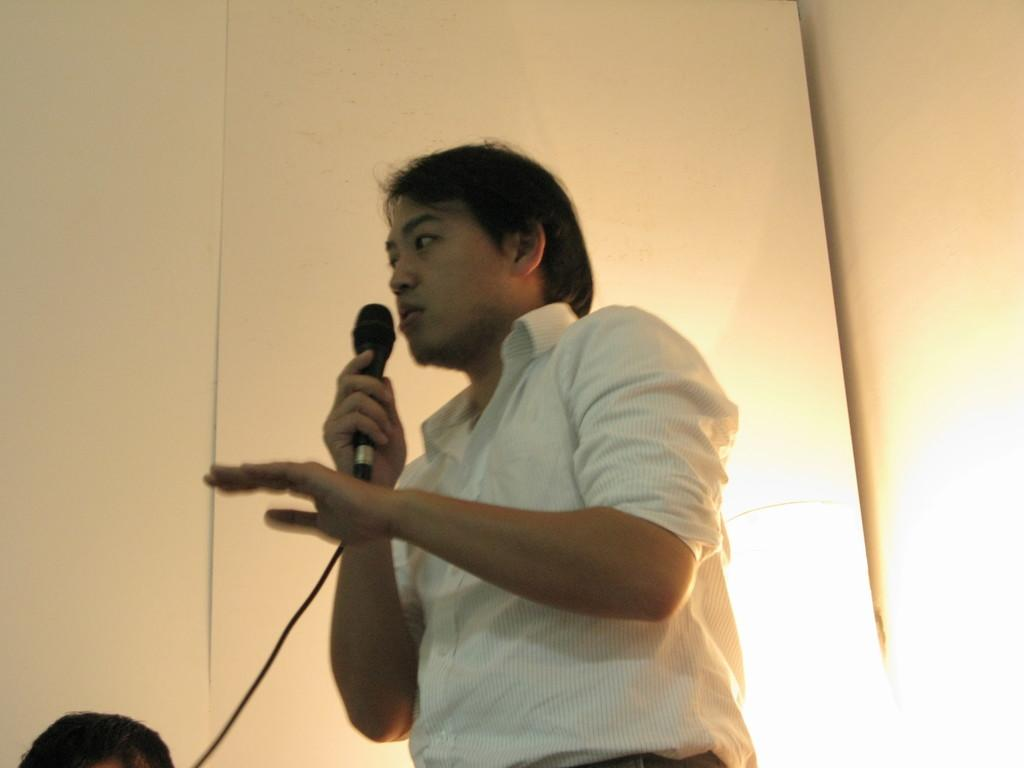What is the main subject of the image? There is a person in the image. What is the person doing in the image? The person is standing and holding a mic in one of his hands. What can be seen in the background of the image? There are walls and light visible in the background of the image. Can you see any grass in the image? There is no grass visible in the image. Is there a goose playing a drum in the image? There is no goose or drum present in the image. 